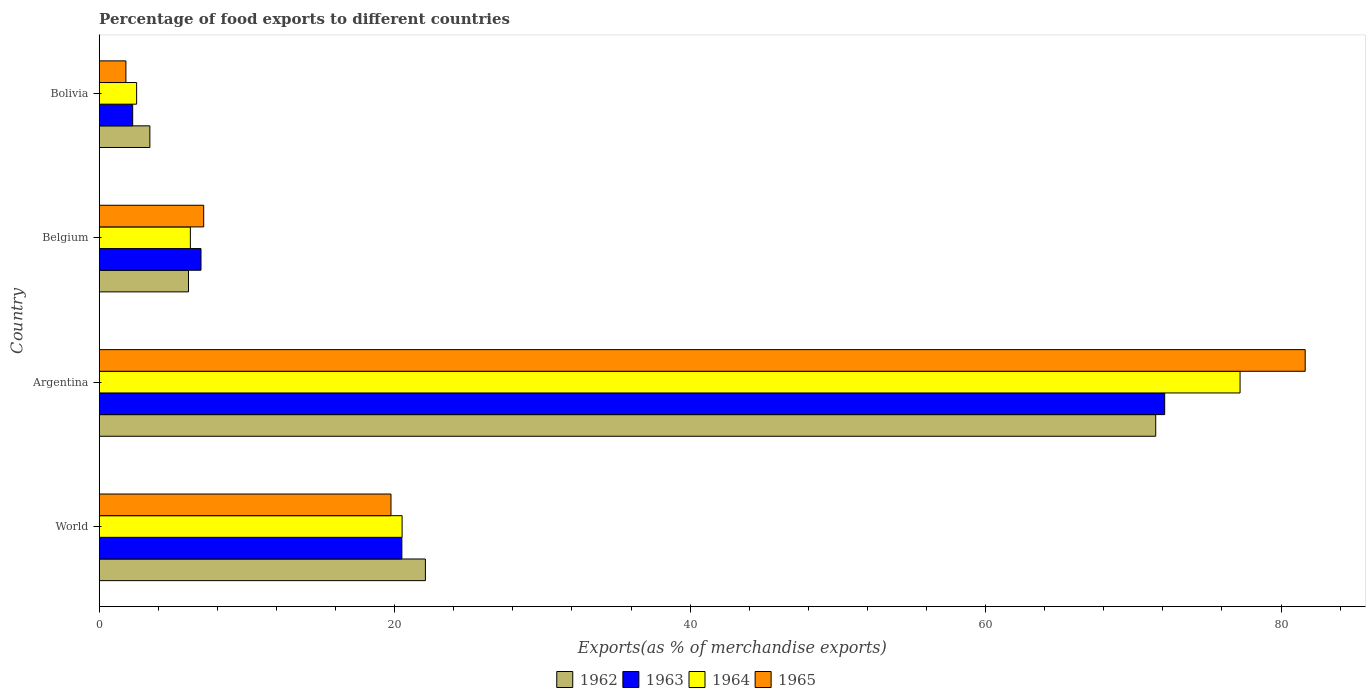Are the number of bars per tick equal to the number of legend labels?
Give a very brief answer. Yes. Are the number of bars on each tick of the Y-axis equal?
Offer a very short reply. Yes. How many bars are there on the 1st tick from the bottom?
Your answer should be compact. 4. In how many cases, is the number of bars for a given country not equal to the number of legend labels?
Your response must be concise. 0. What is the percentage of exports to different countries in 1963 in Bolivia?
Offer a very short reply. 2.27. Across all countries, what is the maximum percentage of exports to different countries in 1965?
Offer a terse response. 81.64. Across all countries, what is the minimum percentage of exports to different countries in 1963?
Make the answer very short. 2.27. In which country was the percentage of exports to different countries in 1963 maximum?
Offer a very short reply. Argentina. In which country was the percentage of exports to different countries in 1963 minimum?
Your answer should be very brief. Bolivia. What is the total percentage of exports to different countries in 1965 in the graph?
Give a very brief answer. 110.27. What is the difference between the percentage of exports to different countries in 1965 in Bolivia and that in World?
Your answer should be compact. -17.94. What is the difference between the percentage of exports to different countries in 1964 in Bolivia and the percentage of exports to different countries in 1962 in Argentina?
Offer a very short reply. -68.98. What is the average percentage of exports to different countries in 1964 per country?
Your answer should be compact. 26.61. What is the difference between the percentage of exports to different countries in 1962 and percentage of exports to different countries in 1963 in Bolivia?
Ensure brevity in your answer.  1.16. What is the ratio of the percentage of exports to different countries in 1964 in Belgium to that in World?
Your answer should be compact. 0.3. Is the percentage of exports to different countries in 1963 in Belgium less than that in World?
Make the answer very short. Yes. Is the difference between the percentage of exports to different countries in 1962 in Argentina and Bolivia greater than the difference between the percentage of exports to different countries in 1963 in Argentina and Bolivia?
Provide a short and direct response. No. What is the difference between the highest and the second highest percentage of exports to different countries in 1964?
Your answer should be very brief. 56.72. What is the difference between the highest and the lowest percentage of exports to different countries in 1963?
Keep it short and to the point. 69.86. In how many countries, is the percentage of exports to different countries in 1964 greater than the average percentage of exports to different countries in 1964 taken over all countries?
Offer a terse response. 1. Is the sum of the percentage of exports to different countries in 1964 in Argentina and Belgium greater than the maximum percentage of exports to different countries in 1965 across all countries?
Keep it short and to the point. Yes. Is it the case that in every country, the sum of the percentage of exports to different countries in 1963 and percentage of exports to different countries in 1965 is greater than the sum of percentage of exports to different countries in 1964 and percentage of exports to different countries in 1962?
Give a very brief answer. No. What does the 4th bar from the top in World represents?
Your response must be concise. 1962. How many bars are there?
Your answer should be very brief. 16. Are all the bars in the graph horizontal?
Your answer should be very brief. Yes. How many countries are there in the graph?
Offer a very short reply. 4. What is the difference between two consecutive major ticks on the X-axis?
Your response must be concise. 20. Does the graph contain any zero values?
Offer a very short reply. No. What is the title of the graph?
Ensure brevity in your answer.  Percentage of food exports to different countries. Does "1963" appear as one of the legend labels in the graph?
Offer a terse response. Yes. What is the label or title of the X-axis?
Offer a very short reply. Exports(as % of merchandise exports). What is the Exports(as % of merchandise exports) in 1962 in World?
Your answer should be compact. 22.08. What is the Exports(as % of merchandise exports) of 1963 in World?
Make the answer very short. 20.49. What is the Exports(as % of merchandise exports) in 1964 in World?
Make the answer very short. 20.5. What is the Exports(as % of merchandise exports) in 1965 in World?
Give a very brief answer. 19.75. What is the Exports(as % of merchandise exports) in 1962 in Argentina?
Give a very brief answer. 71.52. What is the Exports(as % of merchandise exports) of 1963 in Argentina?
Give a very brief answer. 72.12. What is the Exports(as % of merchandise exports) of 1964 in Argentina?
Keep it short and to the point. 77.23. What is the Exports(as % of merchandise exports) in 1965 in Argentina?
Provide a succinct answer. 81.64. What is the Exports(as % of merchandise exports) of 1962 in Belgium?
Keep it short and to the point. 6.04. What is the Exports(as % of merchandise exports) in 1963 in Belgium?
Offer a terse response. 6.89. What is the Exports(as % of merchandise exports) in 1964 in Belgium?
Your answer should be compact. 6.17. What is the Exports(as % of merchandise exports) of 1965 in Belgium?
Make the answer very short. 7.07. What is the Exports(as % of merchandise exports) of 1962 in Bolivia?
Provide a short and direct response. 3.43. What is the Exports(as % of merchandise exports) in 1963 in Bolivia?
Make the answer very short. 2.27. What is the Exports(as % of merchandise exports) in 1964 in Bolivia?
Your answer should be compact. 2.53. What is the Exports(as % of merchandise exports) of 1965 in Bolivia?
Give a very brief answer. 1.81. Across all countries, what is the maximum Exports(as % of merchandise exports) in 1962?
Offer a very short reply. 71.52. Across all countries, what is the maximum Exports(as % of merchandise exports) of 1963?
Keep it short and to the point. 72.12. Across all countries, what is the maximum Exports(as % of merchandise exports) in 1964?
Your answer should be compact. 77.23. Across all countries, what is the maximum Exports(as % of merchandise exports) of 1965?
Ensure brevity in your answer.  81.64. Across all countries, what is the minimum Exports(as % of merchandise exports) in 1962?
Make the answer very short. 3.43. Across all countries, what is the minimum Exports(as % of merchandise exports) in 1963?
Your response must be concise. 2.27. Across all countries, what is the minimum Exports(as % of merchandise exports) of 1964?
Offer a very short reply. 2.53. Across all countries, what is the minimum Exports(as % of merchandise exports) in 1965?
Make the answer very short. 1.81. What is the total Exports(as % of merchandise exports) in 1962 in the graph?
Give a very brief answer. 103.07. What is the total Exports(as % of merchandise exports) of 1963 in the graph?
Make the answer very short. 101.77. What is the total Exports(as % of merchandise exports) of 1964 in the graph?
Your answer should be compact. 106.43. What is the total Exports(as % of merchandise exports) in 1965 in the graph?
Your answer should be compact. 110.27. What is the difference between the Exports(as % of merchandise exports) in 1962 in World and that in Argentina?
Your answer should be compact. -49.44. What is the difference between the Exports(as % of merchandise exports) in 1963 in World and that in Argentina?
Your answer should be very brief. -51.64. What is the difference between the Exports(as % of merchandise exports) of 1964 in World and that in Argentina?
Provide a succinct answer. -56.72. What is the difference between the Exports(as % of merchandise exports) in 1965 in World and that in Argentina?
Your response must be concise. -61.88. What is the difference between the Exports(as % of merchandise exports) in 1962 in World and that in Belgium?
Ensure brevity in your answer.  16.04. What is the difference between the Exports(as % of merchandise exports) of 1963 in World and that in Belgium?
Your answer should be compact. 13.6. What is the difference between the Exports(as % of merchandise exports) in 1964 in World and that in Belgium?
Your answer should be compact. 14.33. What is the difference between the Exports(as % of merchandise exports) in 1965 in World and that in Belgium?
Ensure brevity in your answer.  12.68. What is the difference between the Exports(as % of merchandise exports) in 1962 in World and that in Bolivia?
Ensure brevity in your answer.  18.65. What is the difference between the Exports(as % of merchandise exports) of 1963 in World and that in Bolivia?
Your answer should be compact. 18.22. What is the difference between the Exports(as % of merchandise exports) of 1964 in World and that in Bolivia?
Your response must be concise. 17.97. What is the difference between the Exports(as % of merchandise exports) in 1965 in World and that in Bolivia?
Keep it short and to the point. 17.94. What is the difference between the Exports(as % of merchandise exports) in 1962 in Argentina and that in Belgium?
Give a very brief answer. 65.47. What is the difference between the Exports(as % of merchandise exports) of 1963 in Argentina and that in Belgium?
Offer a very short reply. 65.23. What is the difference between the Exports(as % of merchandise exports) in 1964 in Argentina and that in Belgium?
Give a very brief answer. 71.06. What is the difference between the Exports(as % of merchandise exports) in 1965 in Argentina and that in Belgium?
Your answer should be compact. 74.56. What is the difference between the Exports(as % of merchandise exports) of 1962 in Argentina and that in Bolivia?
Your answer should be compact. 68.09. What is the difference between the Exports(as % of merchandise exports) in 1963 in Argentina and that in Bolivia?
Ensure brevity in your answer.  69.86. What is the difference between the Exports(as % of merchandise exports) in 1964 in Argentina and that in Bolivia?
Make the answer very short. 74.69. What is the difference between the Exports(as % of merchandise exports) in 1965 in Argentina and that in Bolivia?
Your response must be concise. 79.83. What is the difference between the Exports(as % of merchandise exports) in 1962 in Belgium and that in Bolivia?
Offer a very short reply. 2.61. What is the difference between the Exports(as % of merchandise exports) of 1963 in Belgium and that in Bolivia?
Make the answer very short. 4.62. What is the difference between the Exports(as % of merchandise exports) of 1964 in Belgium and that in Bolivia?
Provide a succinct answer. 3.64. What is the difference between the Exports(as % of merchandise exports) in 1965 in Belgium and that in Bolivia?
Your answer should be compact. 5.27. What is the difference between the Exports(as % of merchandise exports) in 1962 in World and the Exports(as % of merchandise exports) in 1963 in Argentina?
Make the answer very short. -50.04. What is the difference between the Exports(as % of merchandise exports) in 1962 in World and the Exports(as % of merchandise exports) in 1964 in Argentina?
Offer a terse response. -55.15. What is the difference between the Exports(as % of merchandise exports) of 1962 in World and the Exports(as % of merchandise exports) of 1965 in Argentina?
Ensure brevity in your answer.  -59.55. What is the difference between the Exports(as % of merchandise exports) of 1963 in World and the Exports(as % of merchandise exports) of 1964 in Argentina?
Your answer should be very brief. -56.74. What is the difference between the Exports(as % of merchandise exports) in 1963 in World and the Exports(as % of merchandise exports) in 1965 in Argentina?
Keep it short and to the point. -61.15. What is the difference between the Exports(as % of merchandise exports) in 1964 in World and the Exports(as % of merchandise exports) in 1965 in Argentina?
Give a very brief answer. -61.13. What is the difference between the Exports(as % of merchandise exports) of 1962 in World and the Exports(as % of merchandise exports) of 1963 in Belgium?
Provide a succinct answer. 15.19. What is the difference between the Exports(as % of merchandise exports) in 1962 in World and the Exports(as % of merchandise exports) in 1964 in Belgium?
Offer a very short reply. 15.91. What is the difference between the Exports(as % of merchandise exports) in 1962 in World and the Exports(as % of merchandise exports) in 1965 in Belgium?
Your answer should be compact. 15.01. What is the difference between the Exports(as % of merchandise exports) of 1963 in World and the Exports(as % of merchandise exports) of 1964 in Belgium?
Keep it short and to the point. 14.32. What is the difference between the Exports(as % of merchandise exports) of 1963 in World and the Exports(as % of merchandise exports) of 1965 in Belgium?
Ensure brevity in your answer.  13.41. What is the difference between the Exports(as % of merchandise exports) in 1964 in World and the Exports(as % of merchandise exports) in 1965 in Belgium?
Keep it short and to the point. 13.43. What is the difference between the Exports(as % of merchandise exports) in 1962 in World and the Exports(as % of merchandise exports) in 1963 in Bolivia?
Offer a very short reply. 19.81. What is the difference between the Exports(as % of merchandise exports) in 1962 in World and the Exports(as % of merchandise exports) in 1964 in Bolivia?
Your answer should be compact. 19.55. What is the difference between the Exports(as % of merchandise exports) in 1962 in World and the Exports(as % of merchandise exports) in 1965 in Bolivia?
Ensure brevity in your answer.  20.27. What is the difference between the Exports(as % of merchandise exports) of 1963 in World and the Exports(as % of merchandise exports) of 1964 in Bolivia?
Offer a very short reply. 17.95. What is the difference between the Exports(as % of merchandise exports) of 1963 in World and the Exports(as % of merchandise exports) of 1965 in Bolivia?
Offer a terse response. 18.68. What is the difference between the Exports(as % of merchandise exports) in 1964 in World and the Exports(as % of merchandise exports) in 1965 in Bolivia?
Make the answer very short. 18.7. What is the difference between the Exports(as % of merchandise exports) in 1962 in Argentina and the Exports(as % of merchandise exports) in 1963 in Belgium?
Ensure brevity in your answer.  64.63. What is the difference between the Exports(as % of merchandise exports) of 1962 in Argentina and the Exports(as % of merchandise exports) of 1964 in Belgium?
Provide a succinct answer. 65.35. What is the difference between the Exports(as % of merchandise exports) in 1962 in Argentina and the Exports(as % of merchandise exports) in 1965 in Belgium?
Offer a very short reply. 64.44. What is the difference between the Exports(as % of merchandise exports) of 1963 in Argentina and the Exports(as % of merchandise exports) of 1964 in Belgium?
Your response must be concise. 65.95. What is the difference between the Exports(as % of merchandise exports) of 1963 in Argentina and the Exports(as % of merchandise exports) of 1965 in Belgium?
Your response must be concise. 65.05. What is the difference between the Exports(as % of merchandise exports) in 1964 in Argentina and the Exports(as % of merchandise exports) in 1965 in Belgium?
Provide a short and direct response. 70.15. What is the difference between the Exports(as % of merchandise exports) of 1962 in Argentina and the Exports(as % of merchandise exports) of 1963 in Bolivia?
Keep it short and to the point. 69.25. What is the difference between the Exports(as % of merchandise exports) of 1962 in Argentina and the Exports(as % of merchandise exports) of 1964 in Bolivia?
Your answer should be very brief. 68.98. What is the difference between the Exports(as % of merchandise exports) of 1962 in Argentina and the Exports(as % of merchandise exports) of 1965 in Bolivia?
Offer a very short reply. 69.71. What is the difference between the Exports(as % of merchandise exports) in 1963 in Argentina and the Exports(as % of merchandise exports) in 1964 in Bolivia?
Make the answer very short. 69.59. What is the difference between the Exports(as % of merchandise exports) of 1963 in Argentina and the Exports(as % of merchandise exports) of 1965 in Bolivia?
Make the answer very short. 70.32. What is the difference between the Exports(as % of merchandise exports) in 1964 in Argentina and the Exports(as % of merchandise exports) in 1965 in Bolivia?
Your response must be concise. 75.42. What is the difference between the Exports(as % of merchandise exports) of 1962 in Belgium and the Exports(as % of merchandise exports) of 1963 in Bolivia?
Provide a succinct answer. 3.78. What is the difference between the Exports(as % of merchandise exports) in 1962 in Belgium and the Exports(as % of merchandise exports) in 1964 in Bolivia?
Offer a terse response. 3.51. What is the difference between the Exports(as % of merchandise exports) of 1962 in Belgium and the Exports(as % of merchandise exports) of 1965 in Bolivia?
Offer a terse response. 4.24. What is the difference between the Exports(as % of merchandise exports) in 1963 in Belgium and the Exports(as % of merchandise exports) in 1964 in Bolivia?
Provide a short and direct response. 4.36. What is the difference between the Exports(as % of merchandise exports) in 1963 in Belgium and the Exports(as % of merchandise exports) in 1965 in Bolivia?
Provide a short and direct response. 5.08. What is the difference between the Exports(as % of merchandise exports) of 1964 in Belgium and the Exports(as % of merchandise exports) of 1965 in Bolivia?
Offer a terse response. 4.36. What is the average Exports(as % of merchandise exports) of 1962 per country?
Offer a very short reply. 25.77. What is the average Exports(as % of merchandise exports) in 1963 per country?
Offer a terse response. 25.44. What is the average Exports(as % of merchandise exports) of 1964 per country?
Your response must be concise. 26.61. What is the average Exports(as % of merchandise exports) of 1965 per country?
Ensure brevity in your answer.  27.57. What is the difference between the Exports(as % of merchandise exports) in 1962 and Exports(as % of merchandise exports) in 1963 in World?
Provide a succinct answer. 1.59. What is the difference between the Exports(as % of merchandise exports) of 1962 and Exports(as % of merchandise exports) of 1964 in World?
Offer a very short reply. 1.58. What is the difference between the Exports(as % of merchandise exports) in 1962 and Exports(as % of merchandise exports) in 1965 in World?
Make the answer very short. 2.33. What is the difference between the Exports(as % of merchandise exports) in 1963 and Exports(as % of merchandise exports) in 1964 in World?
Your answer should be compact. -0.02. What is the difference between the Exports(as % of merchandise exports) of 1963 and Exports(as % of merchandise exports) of 1965 in World?
Keep it short and to the point. 0.74. What is the difference between the Exports(as % of merchandise exports) of 1964 and Exports(as % of merchandise exports) of 1965 in World?
Your answer should be very brief. 0.75. What is the difference between the Exports(as % of merchandise exports) of 1962 and Exports(as % of merchandise exports) of 1963 in Argentina?
Your answer should be very brief. -0.61. What is the difference between the Exports(as % of merchandise exports) in 1962 and Exports(as % of merchandise exports) in 1964 in Argentina?
Your response must be concise. -5.71. What is the difference between the Exports(as % of merchandise exports) in 1962 and Exports(as % of merchandise exports) in 1965 in Argentina?
Your answer should be compact. -10.12. What is the difference between the Exports(as % of merchandise exports) in 1963 and Exports(as % of merchandise exports) in 1964 in Argentina?
Make the answer very short. -5.1. What is the difference between the Exports(as % of merchandise exports) in 1963 and Exports(as % of merchandise exports) in 1965 in Argentina?
Your response must be concise. -9.51. What is the difference between the Exports(as % of merchandise exports) of 1964 and Exports(as % of merchandise exports) of 1965 in Argentina?
Keep it short and to the point. -4.41. What is the difference between the Exports(as % of merchandise exports) in 1962 and Exports(as % of merchandise exports) in 1963 in Belgium?
Your answer should be compact. -0.85. What is the difference between the Exports(as % of merchandise exports) of 1962 and Exports(as % of merchandise exports) of 1964 in Belgium?
Your answer should be compact. -0.13. What is the difference between the Exports(as % of merchandise exports) in 1962 and Exports(as % of merchandise exports) in 1965 in Belgium?
Offer a terse response. -1.03. What is the difference between the Exports(as % of merchandise exports) in 1963 and Exports(as % of merchandise exports) in 1964 in Belgium?
Provide a short and direct response. 0.72. What is the difference between the Exports(as % of merchandise exports) in 1963 and Exports(as % of merchandise exports) in 1965 in Belgium?
Offer a very short reply. -0.18. What is the difference between the Exports(as % of merchandise exports) in 1964 and Exports(as % of merchandise exports) in 1965 in Belgium?
Offer a very short reply. -0.9. What is the difference between the Exports(as % of merchandise exports) in 1962 and Exports(as % of merchandise exports) in 1963 in Bolivia?
Your answer should be very brief. 1.16. What is the difference between the Exports(as % of merchandise exports) of 1962 and Exports(as % of merchandise exports) of 1964 in Bolivia?
Your answer should be compact. 0.9. What is the difference between the Exports(as % of merchandise exports) in 1962 and Exports(as % of merchandise exports) in 1965 in Bolivia?
Offer a terse response. 1.62. What is the difference between the Exports(as % of merchandise exports) of 1963 and Exports(as % of merchandise exports) of 1964 in Bolivia?
Your response must be concise. -0.27. What is the difference between the Exports(as % of merchandise exports) in 1963 and Exports(as % of merchandise exports) in 1965 in Bolivia?
Give a very brief answer. 0.46. What is the difference between the Exports(as % of merchandise exports) of 1964 and Exports(as % of merchandise exports) of 1965 in Bolivia?
Make the answer very short. 0.73. What is the ratio of the Exports(as % of merchandise exports) of 1962 in World to that in Argentina?
Your response must be concise. 0.31. What is the ratio of the Exports(as % of merchandise exports) in 1963 in World to that in Argentina?
Provide a succinct answer. 0.28. What is the ratio of the Exports(as % of merchandise exports) in 1964 in World to that in Argentina?
Your answer should be very brief. 0.27. What is the ratio of the Exports(as % of merchandise exports) in 1965 in World to that in Argentina?
Ensure brevity in your answer.  0.24. What is the ratio of the Exports(as % of merchandise exports) of 1962 in World to that in Belgium?
Offer a very short reply. 3.65. What is the ratio of the Exports(as % of merchandise exports) of 1963 in World to that in Belgium?
Keep it short and to the point. 2.97. What is the ratio of the Exports(as % of merchandise exports) of 1964 in World to that in Belgium?
Provide a short and direct response. 3.32. What is the ratio of the Exports(as % of merchandise exports) in 1965 in World to that in Belgium?
Keep it short and to the point. 2.79. What is the ratio of the Exports(as % of merchandise exports) in 1962 in World to that in Bolivia?
Ensure brevity in your answer.  6.44. What is the ratio of the Exports(as % of merchandise exports) in 1963 in World to that in Bolivia?
Keep it short and to the point. 9.04. What is the ratio of the Exports(as % of merchandise exports) of 1964 in World to that in Bolivia?
Your answer should be compact. 8.1. What is the ratio of the Exports(as % of merchandise exports) of 1965 in World to that in Bolivia?
Ensure brevity in your answer.  10.93. What is the ratio of the Exports(as % of merchandise exports) of 1962 in Argentina to that in Belgium?
Keep it short and to the point. 11.84. What is the ratio of the Exports(as % of merchandise exports) of 1963 in Argentina to that in Belgium?
Give a very brief answer. 10.47. What is the ratio of the Exports(as % of merchandise exports) of 1964 in Argentina to that in Belgium?
Ensure brevity in your answer.  12.52. What is the ratio of the Exports(as % of merchandise exports) of 1965 in Argentina to that in Belgium?
Make the answer very short. 11.54. What is the ratio of the Exports(as % of merchandise exports) in 1962 in Argentina to that in Bolivia?
Make the answer very short. 20.86. What is the ratio of the Exports(as % of merchandise exports) in 1963 in Argentina to that in Bolivia?
Offer a very short reply. 31.83. What is the ratio of the Exports(as % of merchandise exports) of 1964 in Argentina to that in Bolivia?
Keep it short and to the point. 30.5. What is the ratio of the Exports(as % of merchandise exports) of 1965 in Argentina to that in Bolivia?
Provide a succinct answer. 45.18. What is the ratio of the Exports(as % of merchandise exports) of 1962 in Belgium to that in Bolivia?
Ensure brevity in your answer.  1.76. What is the ratio of the Exports(as % of merchandise exports) of 1963 in Belgium to that in Bolivia?
Your answer should be very brief. 3.04. What is the ratio of the Exports(as % of merchandise exports) of 1964 in Belgium to that in Bolivia?
Give a very brief answer. 2.44. What is the ratio of the Exports(as % of merchandise exports) of 1965 in Belgium to that in Bolivia?
Give a very brief answer. 3.91. What is the difference between the highest and the second highest Exports(as % of merchandise exports) in 1962?
Provide a succinct answer. 49.44. What is the difference between the highest and the second highest Exports(as % of merchandise exports) in 1963?
Give a very brief answer. 51.64. What is the difference between the highest and the second highest Exports(as % of merchandise exports) of 1964?
Provide a succinct answer. 56.72. What is the difference between the highest and the second highest Exports(as % of merchandise exports) in 1965?
Keep it short and to the point. 61.88. What is the difference between the highest and the lowest Exports(as % of merchandise exports) of 1962?
Give a very brief answer. 68.09. What is the difference between the highest and the lowest Exports(as % of merchandise exports) in 1963?
Provide a short and direct response. 69.86. What is the difference between the highest and the lowest Exports(as % of merchandise exports) in 1964?
Provide a succinct answer. 74.69. What is the difference between the highest and the lowest Exports(as % of merchandise exports) in 1965?
Offer a very short reply. 79.83. 